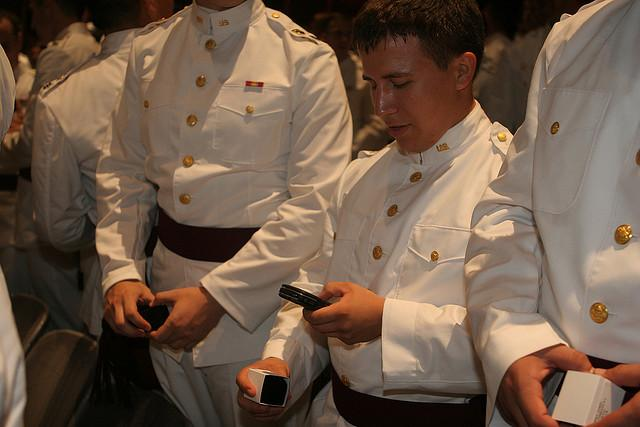What is the short man doing?

Choices:
A) texting
B) playing game
C) taking photo
D) online shopping taking photo 